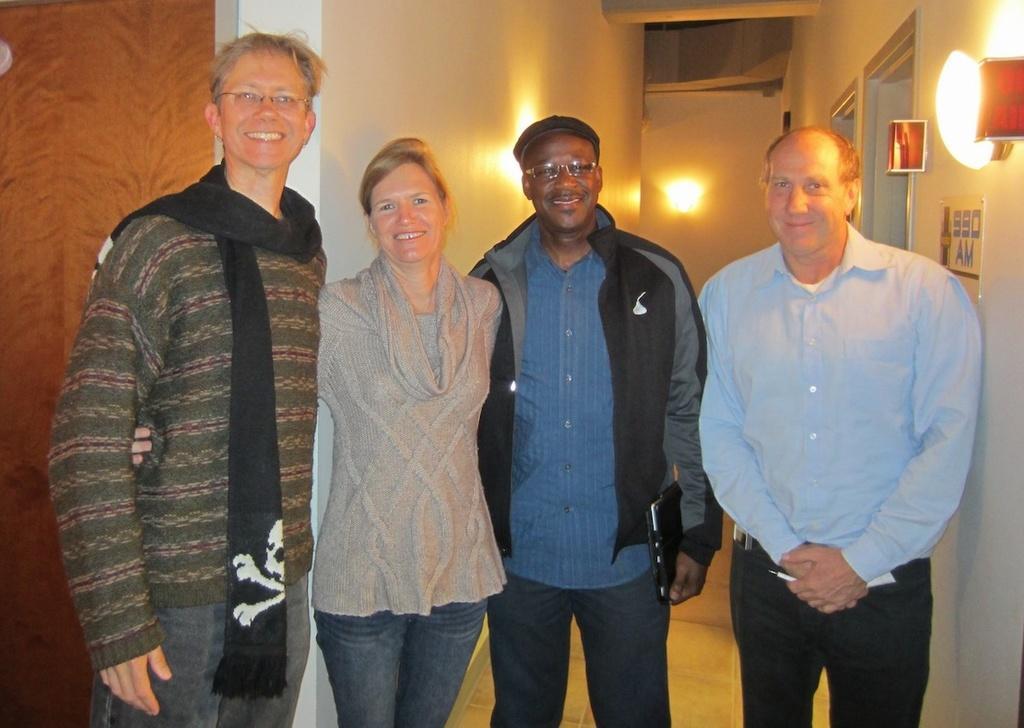Describe this image in one or two sentences. In this picture I can see 3 men and a woman standing in front and I see that they're smiling. In the background I can see the walls and I can see the lights. On the right side of this picture, I can see a board and I see something is written on it. 